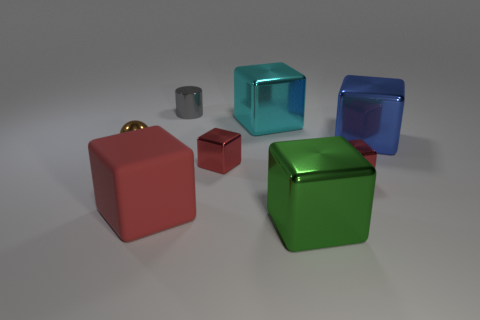Subtract all blue balls. How many red cubes are left? 3 Subtract all cyan blocks. How many blocks are left? 5 Subtract all big rubber blocks. How many blocks are left? 5 Subtract all gray cubes. Subtract all purple cylinders. How many cubes are left? 6 Add 2 metallic cylinders. How many objects exist? 10 Subtract all cylinders. How many objects are left? 7 Add 4 big red metal cubes. How many big red metal cubes exist? 4 Subtract 0 blue cylinders. How many objects are left? 8 Subtract all blue metallic things. Subtract all small things. How many objects are left? 3 Add 6 cyan cubes. How many cyan cubes are left? 7 